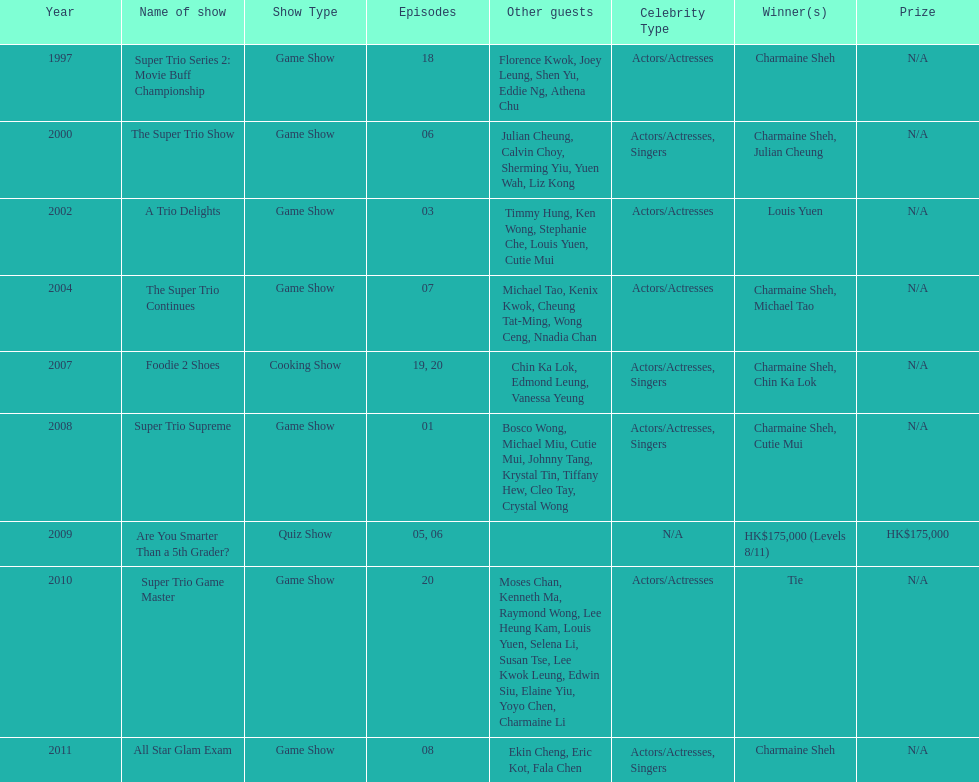In the variety show super trio 2: movie buff champions, how many episodes featured charmaine sheh? 18. 